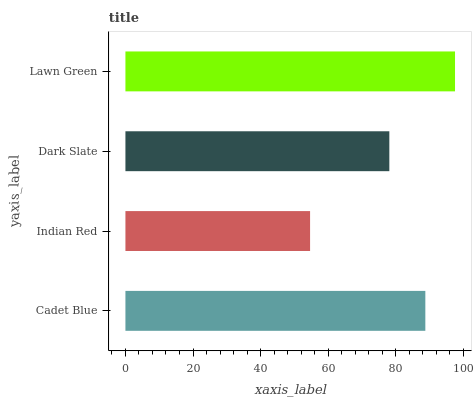Is Indian Red the minimum?
Answer yes or no. Yes. Is Lawn Green the maximum?
Answer yes or no. Yes. Is Dark Slate the minimum?
Answer yes or no. No. Is Dark Slate the maximum?
Answer yes or no. No. Is Dark Slate greater than Indian Red?
Answer yes or no. Yes. Is Indian Red less than Dark Slate?
Answer yes or no. Yes. Is Indian Red greater than Dark Slate?
Answer yes or no. No. Is Dark Slate less than Indian Red?
Answer yes or no. No. Is Cadet Blue the high median?
Answer yes or no. Yes. Is Dark Slate the low median?
Answer yes or no. Yes. Is Indian Red the high median?
Answer yes or no. No. Is Lawn Green the low median?
Answer yes or no. No. 